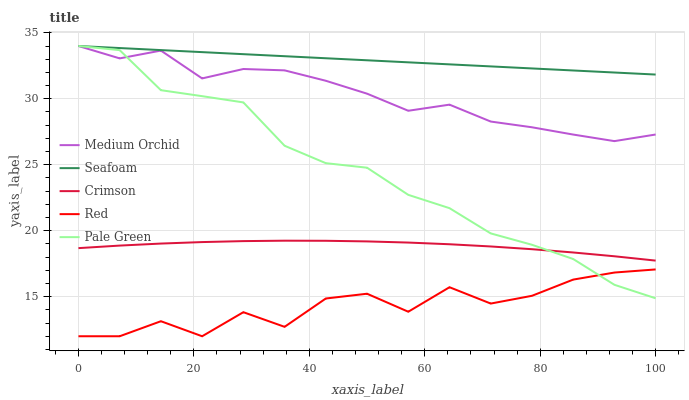Does Red have the minimum area under the curve?
Answer yes or no. Yes. Does Seafoam have the maximum area under the curve?
Answer yes or no. Yes. Does Pale Green have the minimum area under the curve?
Answer yes or no. No. Does Pale Green have the maximum area under the curve?
Answer yes or no. No. Is Seafoam the smoothest?
Answer yes or no. Yes. Is Red the roughest?
Answer yes or no. Yes. Is Pale Green the smoothest?
Answer yes or no. No. Is Pale Green the roughest?
Answer yes or no. No. Does Red have the lowest value?
Answer yes or no. Yes. Does Pale Green have the lowest value?
Answer yes or no. No. Does Seafoam have the highest value?
Answer yes or no. Yes. Does Red have the highest value?
Answer yes or no. No. Is Red less than Crimson?
Answer yes or no. Yes. Is Crimson greater than Red?
Answer yes or no. Yes. Does Medium Orchid intersect Seafoam?
Answer yes or no. Yes. Is Medium Orchid less than Seafoam?
Answer yes or no. No. Is Medium Orchid greater than Seafoam?
Answer yes or no. No. Does Red intersect Crimson?
Answer yes or no. No. 